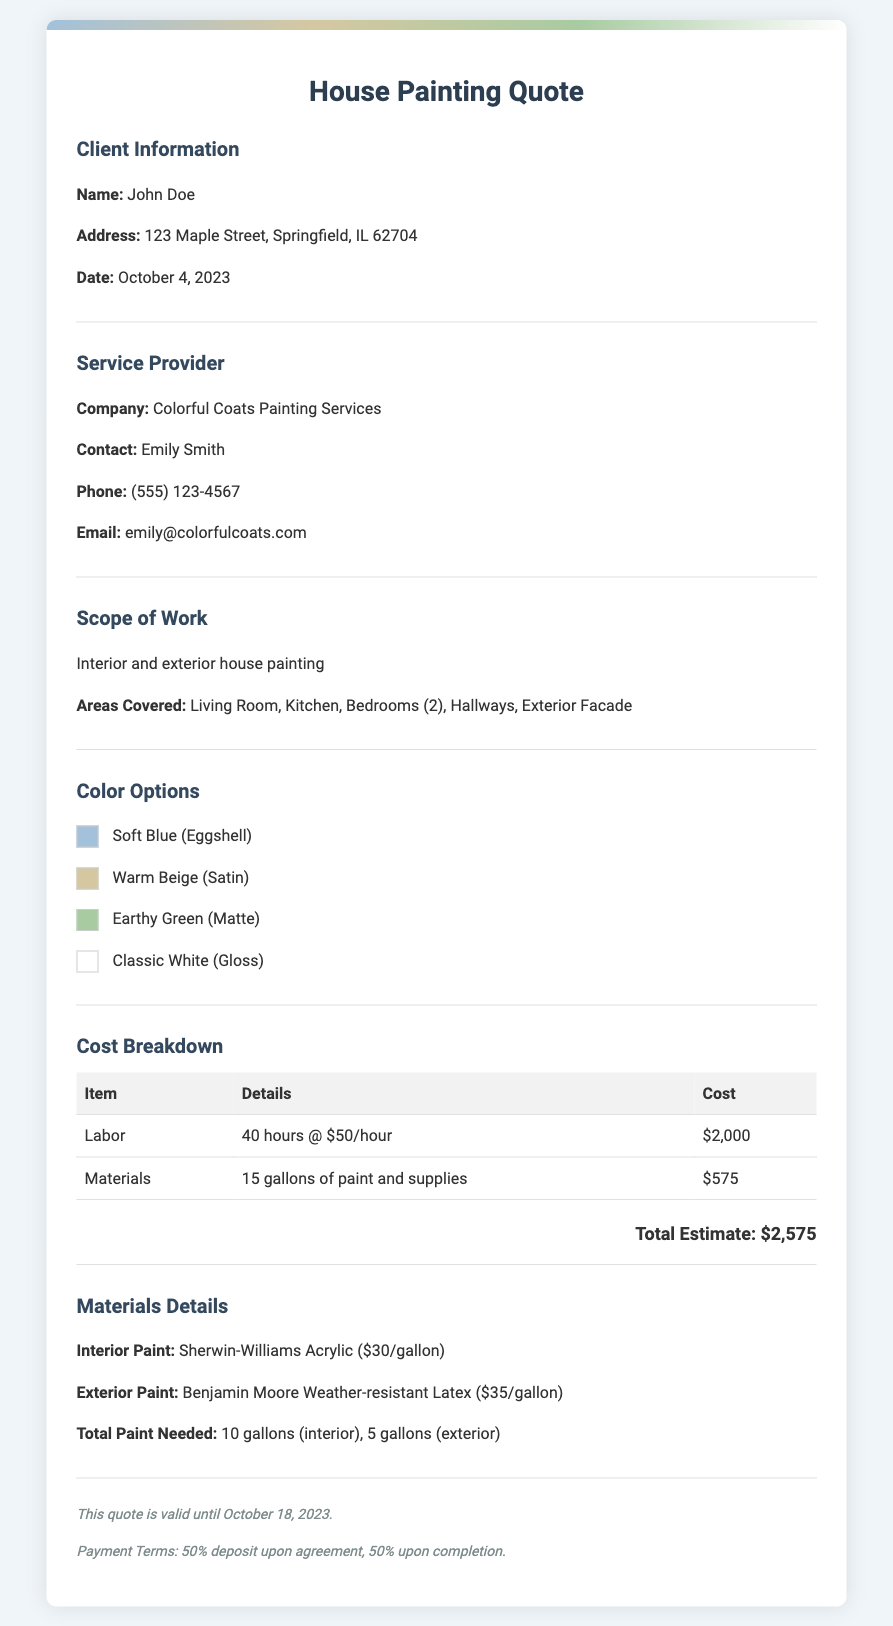What is the client's name? The client's name is provided in the document under Client Information.
Answer: John Doe What is the total cost estimate? The total cost estimate is shown in the Cost Breakdown section of the document.
Answer: $2,575 How many gallons of paint are needed for the exterior? The total paint needed is specified in the Materials Details section of the document.
Answer: 5 gallons What is the date when this quote was issued? The date of the quote is included in the Client Information section.
Answer: October 4, 2023 What type of service is provided according to the document? The type of service is mentioned in the Scope of Work section.
Answer: Interior and exterior house painting What color option uses a matte finish? The color options with different finishes are listed in the Color Options section.
Answer: Earthy Green What warranty or validity period is mentioned for the quote? The validity period for the quote is included towards the end of the document as a note.
Answer: October 18, 2023 Who should be contacted for this service? The contact person from the service provider is specified in the Service Provider section.
Answer: Emily Smith How much is the labor charge per hour? The labor cost, including the hourly rate, can be found in the Cost Breakdown table.
Answer: $50/hour 